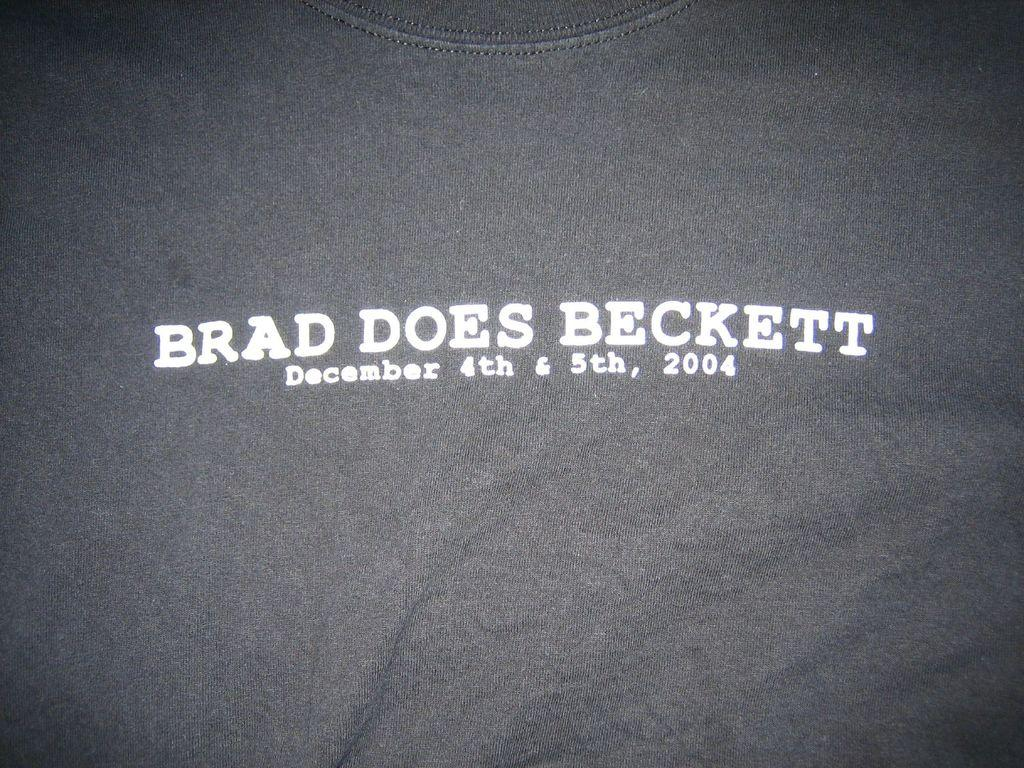What type of clothing item is present in the image? There is a t-shirt in the image. What is featured on the t-shirt? There is text on the t-shirt. What color is the ink used for the text on the door in the image? There is no door or ink present in the image; it only features a t-shirt with text. 